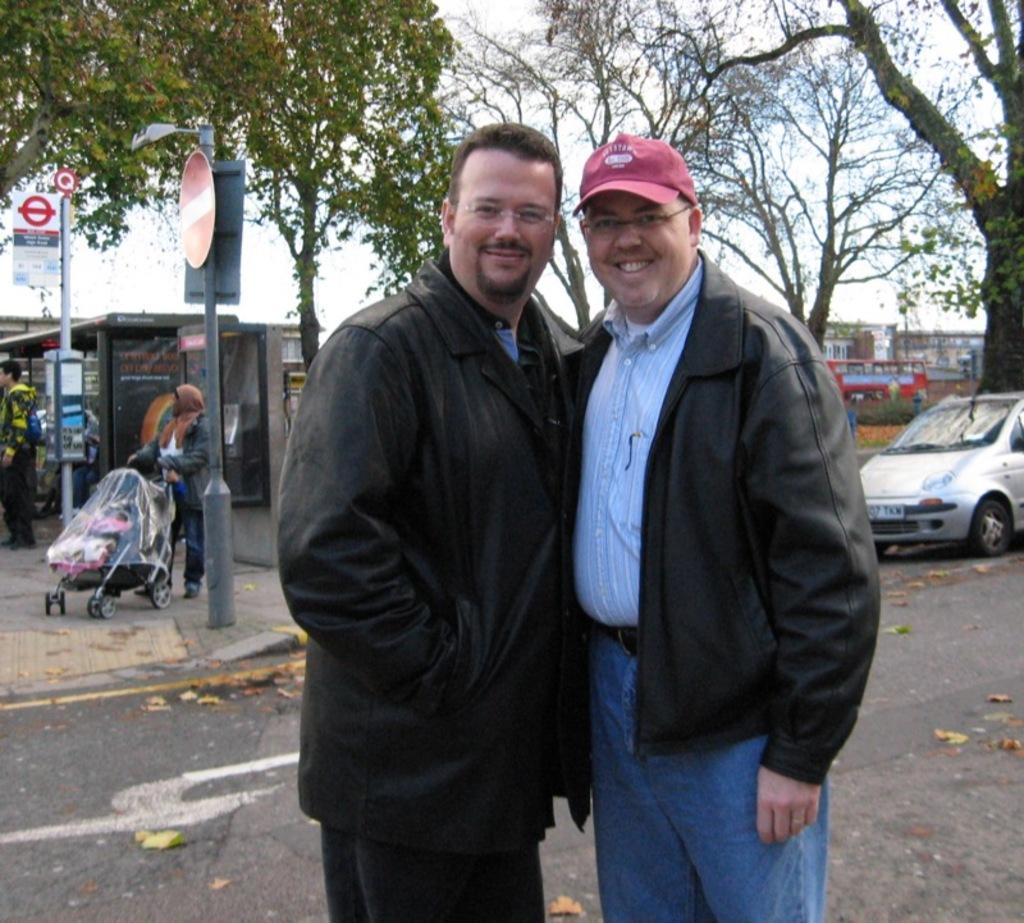Please provide a concise description of this image. In this image there are people standing. There is a road. There are vehicles. We can see many trees. There are other people on the footpath. There is sky. 